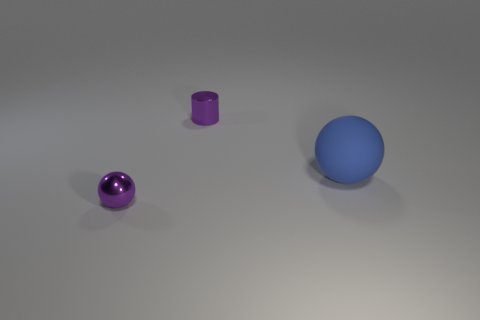Can you describe the color of the objects and estimate their sizes relative to each other? Certainly! There are three objects in the image: a small purple sphere, a medium-sized metallic cylinder, and a larger blue sphere. The purple sphere is the smallest, the metallic cylinder is medium-sized and cylindrical in shape, and the blue sphere is the largest of the three. 